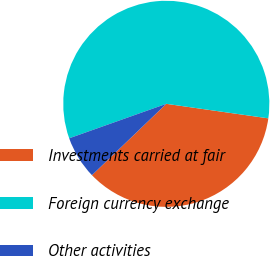<chart> <loc_0><loc_0><loc_500><loc_500><pie_chart><fcel>Investments carried at fair<fcel>Foreign currency exchange<fcel>Other activities<nl><fcel>35.58%<fcel>57.68%<fcel>6.74%<nl></chart> 